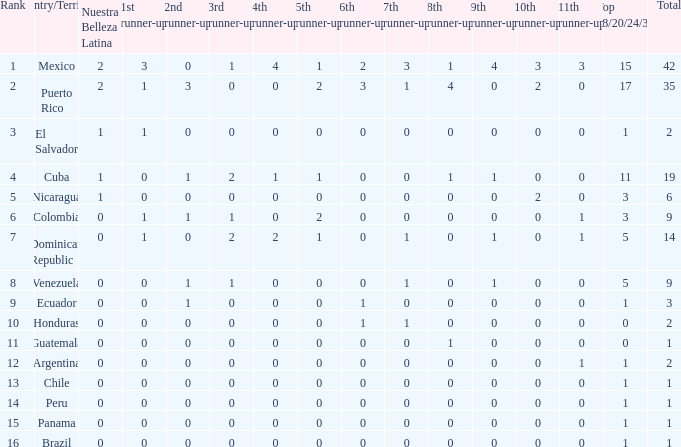How many 3rd runners-up are there in countries with a rank lower than 12, given that they have a 10th runner-up count of 0, an 8th runner-up count of less than 1, and a 7th runner-up count of 0? 4.0. 